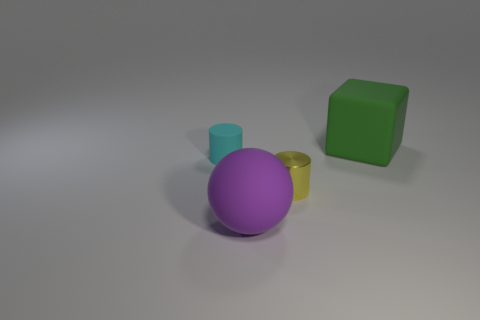There is a big matte object that is behind the small cyan cylinder; is its shape the same as the big rubber object in front of the green cube?
Ensure brevity in your answer.  No. How many rubber objects are both in front of the cyan cylinder and right of the tiny yellow cylinder?
Ensure brevity in your answer.  0. Are there any other matte balls that have the same color as the matte ball?
Provide a succinct answer. No. What is the shape of the yellow object that is the same size as the cyan cylinder?
Offer a very short reply. Cylinder. Are there any cyan matte objects right of the big ball?
Your answer should be compact. No. Is the material of the cylinder that is to the right of the small cyan cylinder the same as the big object in front of the large green thing?
Your answer should be compact. No. What number of cyan matte objects are the same size as the cyan matte cylinder?
Offer a terse response. 0. What is the material of the tiny cylinder on the right side of the purple matte ball?
Provide a short and direct response. Metal. What number of other big green rubber objects have the same shape as the green matte thing?
Offer a terse response. 0. What shape is the large green thing that is the same material as the cyan thing?
Ensure brevity in your answer.  Cube. 